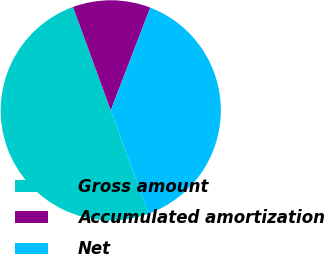Convert chart. <chart><loc_0><loc_0><loc_500><loc_500><pie_chart><fcel>Gross amount<fcel>Accumulated amortization<fcel>Net<nl><fcel>50.0%<fcel>11.42%<fcel>38.58%<nl></chart> 